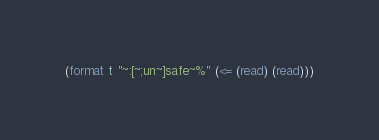<code> <loc_0><loc_0><loc_500><loc_500><_Lisp_>(format t "~:[~;un~]safe~%" (<= (read) (read)))</code> 